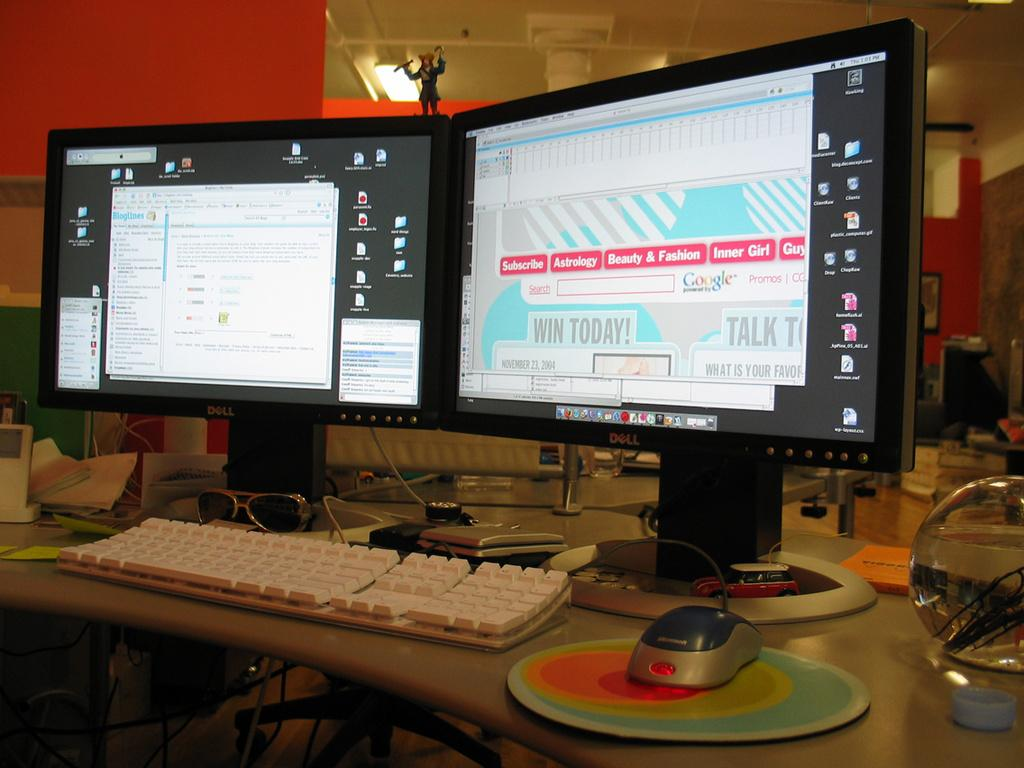<image>
Provide a brief description of the given image. A computer screen displaying different tabs in pink including Subscribe, Astrology, Beauty & Fashion, and Inner Girl. 